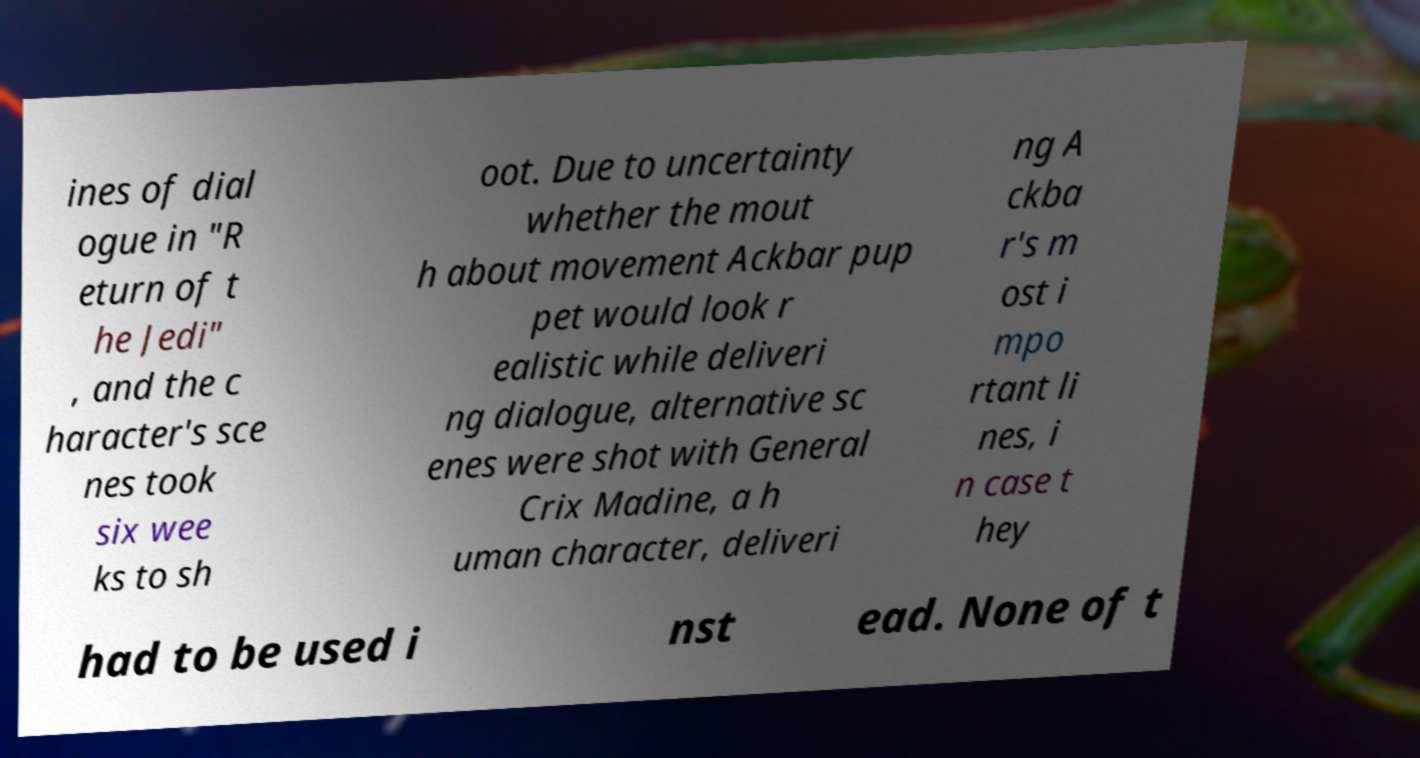There's text embedded in this image that I need extracted. Can you transcribe it verbatim? ines of dial ogue in "R eturn of t he Jedi" , and the c haracter's sce nes took six wee ks to sh oot. Due to uncertainty whether the mout h about movement Ackbar pup pet would look r ealistic while deliveri ng dialogue, alternative sc enes were shot with General Crix Madine, a h uman character, deliveri ng A ckba r's m ost i mpo rtant li nes, i n case t hey had to be used i nst ead. None of t 